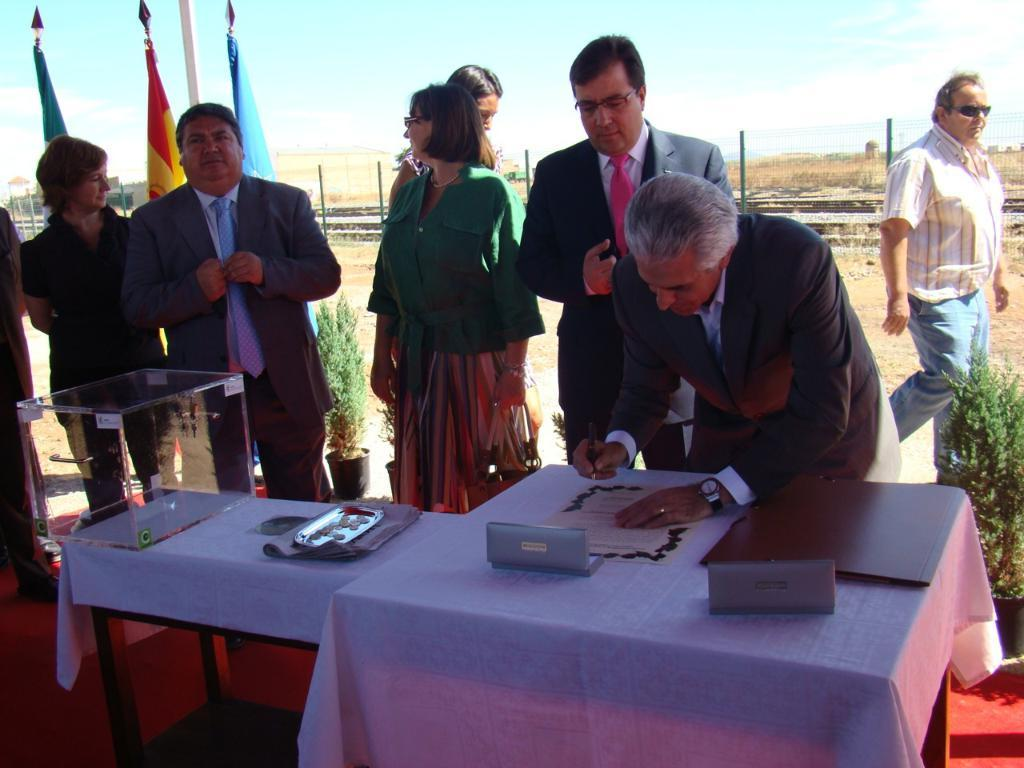What is happening in the image? There are people standing in the image. What can be seen on the table in the image? There is a table in the image, and on it, there is a glass box, a file, and some papers. How many flags are visible in the background of the image? There are three flags in the background of the image. What is visible in the sky in the background of the image? The sky is visible in the background of the image. What is the cause of the end in the image? There is no end or any indication of an ending in the image. Can you describe the cough of the person in the image? There are no people coughing in the image. 